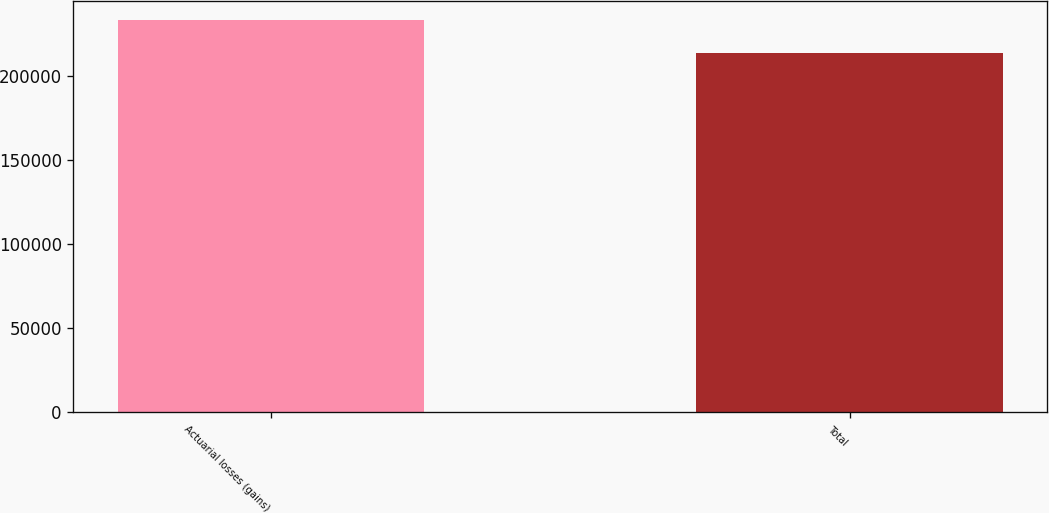<chart> <loc_0><loc_0><loc_500><loc_500><bar_chart><fcel>Actuarial losses (gains)<fcel>Total<nl><fcel>232993<fcel>213702<nl></chart> 